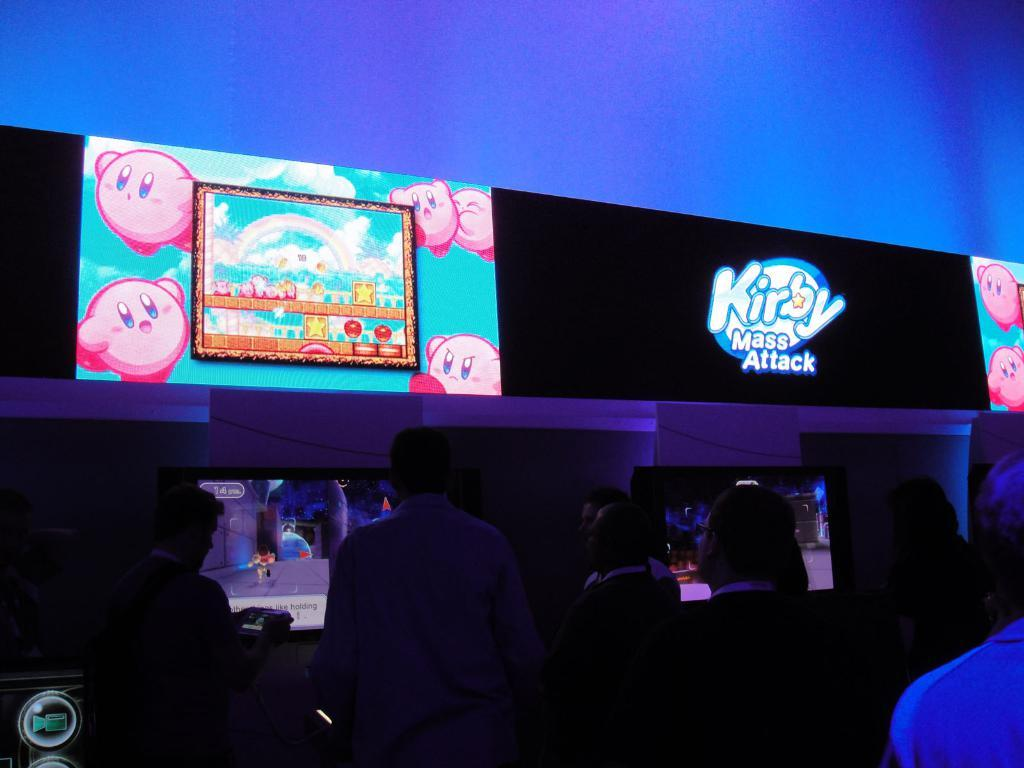How many people are in the image? There is a group of people in the image, but the exact number is not specified. What are the people doing in the image? The people are standing on the floor in front of monitors and screens. What objects are present in the image besides the people? Monitors and screens are present in the image. What type of knife is being used by the person in the image? There is no knife present in the image; the people are standing in front of monitors and screens. 